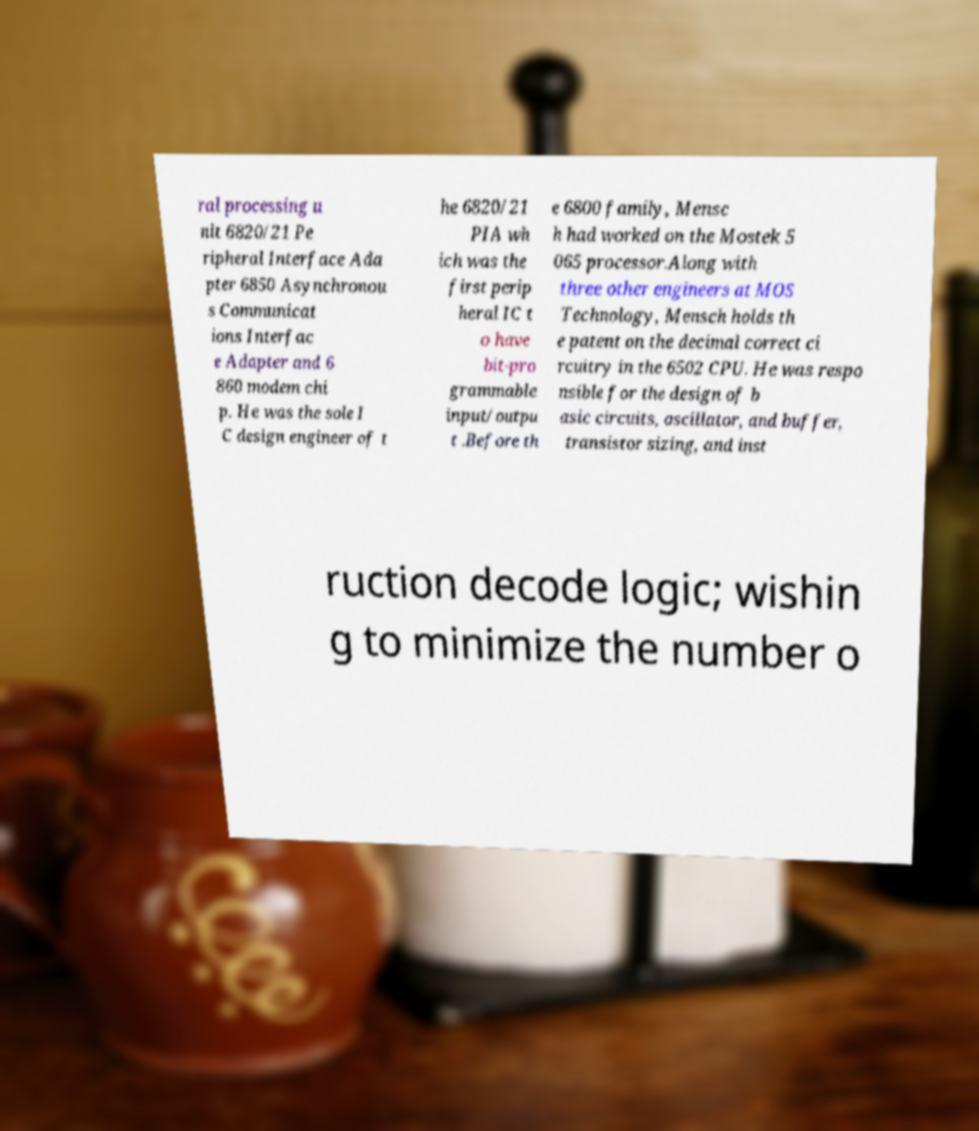There's text embedded in this image that I need extracted. Can you transcribe it verbatim? ral processing u nit 6820/21 Pe ripheral Interface Ada pter 6850 Asynchronou s Communicat ions Interfac e Adapter and 6 860 modem chi p. He was the sole I C design engineer of t he 6820/21 PIA wh ich was the first perip heral IC t o have bit-pro grammable input/outpu t .Before th e 6800 family, Mensc h had worked on the Mostek 5 065 processor.Along with three other engineers at MOS Technology, Mensch holds th e patent on the decimal correct ci rcuitry in the 6502 CPU. He was respo nsible for the design of b asic circuits, oscillator, and buffer, transistor sizing, and inst ruction decode logic; wishin g to minimize the number o 